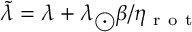<formula> <loc_0><loc_0><loc_500><loc_500>\widetilde { \lambda } = \lambda + \lambda _ { \Big o d o t } \beta / { \eta _ { r o t } }</formula> 